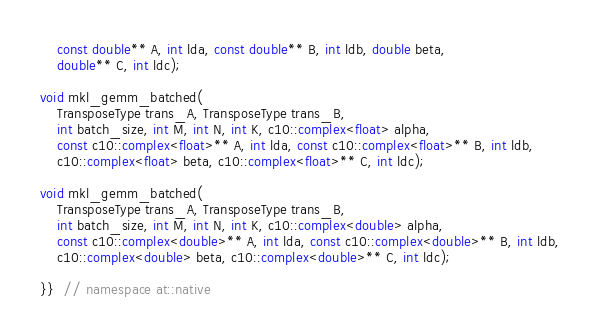<code> <loc_0><loc_0><loc_500><loc_500><_C_>    const double** A, int lda, const double** B, int ldb, double beta,
    double** C, int ldc);

void mkl_gemm_batched(
    TransposeType trans_A, TransposeType trans_B,
    int batch_size, int M, int N, int K, c10::complex<float> alpha,
    const c10::complex<float>** A, int lda, const c10::complex<float>** B, int ldb,
    c10::complex<float> beta, c10::complex<float>** C, int ldc);

void mkl_gemm_batched(
    TransposeType trans_A, TransposeType trans_B,
    int batch_size, int M, int N, int K, c10::complex<double> alpha,
    const c10::complex<double>** A, int lda, const c10::complex<double>** B, int ldb,
    c10::complex<double> beta, c10::complex<double>** C, int ldc);

}}  // namespace at::native
</code> 